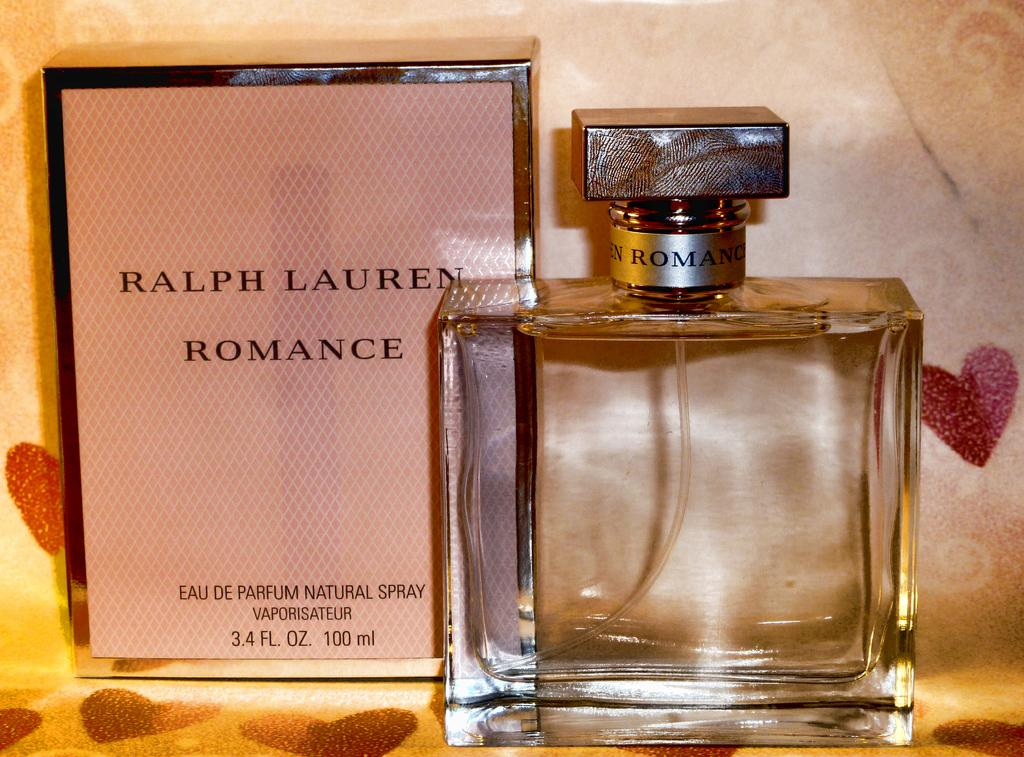<image>
Create a compact narrative representing the image presented. A bottle of perfume is next to a Ralph Lauren perfume box. 